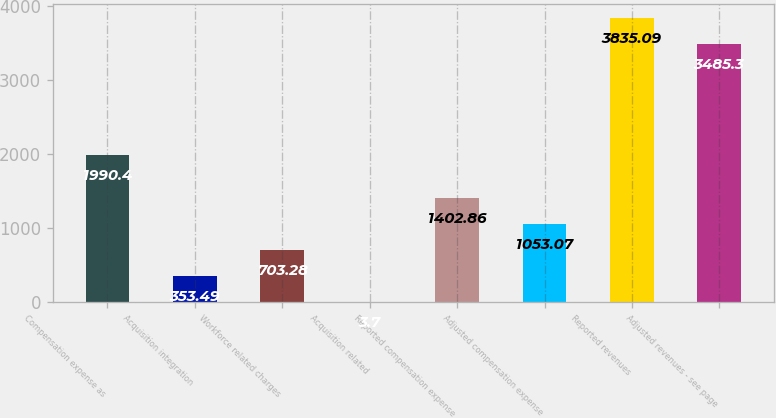Convert chart to OTSL. <chart><loc_0><loc_0><loc_500><loc_500><bar_chart><fcel>Compensation expense as<fcel>Acquisition integration<fcel>Workforce related charges<fcel>Acquisition related<fcel>Reported compensation expense<fcel>Adjusted compensation expense<fcel>Reported revenues<fcel>Adjusted revenues - see page<nl><fcel>1990.4<fcel>353.49<fcel>703.28<fcel>3.7<fcel>1402.86<fcel>1053.07<fcel>3835.09<fcel>3485.3<nl></chart> 